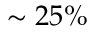Convert formula to latex. <formula><loc_0><loc_0><loc_500><loc_500>\sim 2 5 \%</formula> 